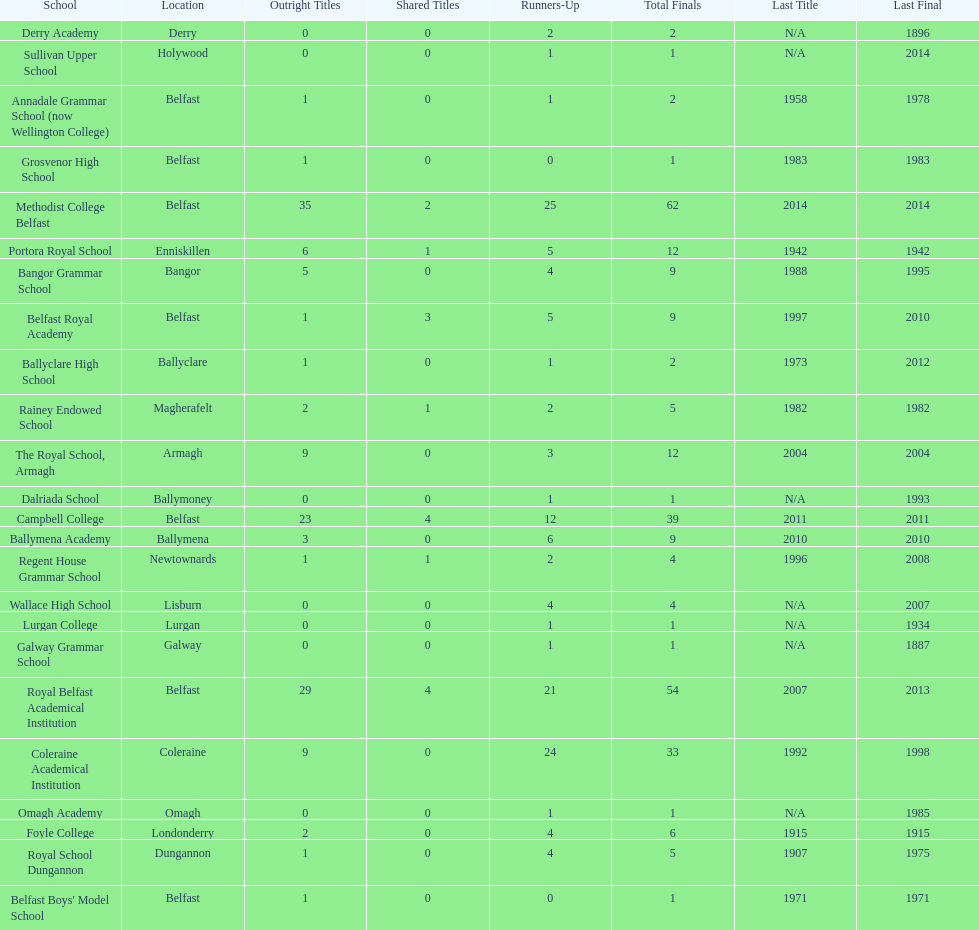Parse the full table. {'header': ['School', 'Location', 'Outright Titles', 'Shared Titles', 'Runners-Up', 'Total Finals', 'Last Title', 'Last Final'], 'rows': [['Derry Academy', 'Derry', '0', '0', '2', '2', 'N/A', '1896'], ['Sullivan Upper School', 'Holywood', '0', '0', '1', '1', 'N/A', '2014'], ['Annadale Grammar School (now Wellington College)', 'Belfast', '1', '0', '1', '2', '1958', '1978'], ['Grosvenor High School', 'Belfast', '1', '0', '0', '1', '1983', '1983'], ['Methodist College Belfast', 'Belfast', '35', '2', '25', '62', '2014', '2014'], ['Portora Royal School', 'Enniskillen', '6', '1', '5', '12', '1942', '1942'], ['Bangor Grammar School', 'Bangor', '5', '0', '4', '9', '1988', '1995'], ['Belfast Royal Academy', 'Belfast', '1', '3', '5', '9', '1997', '2010'], ['Ballyclare High School', 'Ballyclare', '1', '0', '1', '2', '1973', '2012'], ['Rainey Endowed School', 'Magherafelt', '2', '1', '2', '5', '1982', '1982'], ['The Royal School, Armagh', 'Armagh', '9', '0', '3', '12', '2004', '2004'], ['Dalriada School', 'Ballymoney', '0', '0', '1', '1', 'N/A', '1993'], ['Campbell College', 'Belfast', '23', '4', '12', '39', '2011', '2011'], ['Ballymena Academy', 'Ballymena', '3', '0', '6', '9', '2010', '2010'], ['Regent House Grammar School', 'Newtownards', '1', '1', '2', '4', '1996', '2008'], ['Wallace High School', 'Lisburn', '0', '0', '4', '4', 'N/A', '2007'], ['Lurgan College', 'Lurgan', '0', '0', '1', '1', 'N/A', '1934'], ['Galway Grammar School', 'Galway', '0', '0', '1', '1', 'N/A', '1887'], ['Royal Belfast Academical Institution', 'Belfast', '29', '4', '21', '54', '2007', '2013'], ['Coleraine Academical Institution', 'Coleraine', '9', '0', '24', '33', '1992', '1998'], ['Omagh Academy', 'Omagh', '0', '0', '1', '1', 'N/A', '1985'], ['Foyle College', 'Londonderry', '2', '0', '4', '6', '1915', '1915'], ['Royal School Dungannon', 'Dungannon', '1', '0', '4', '5', '1907', '1975'], ["Belfast Boys' Model School", 'Belfast', '1', '0', '0', '1', '1971', '1971']]} What number of total finals does foyle college have? 6. 